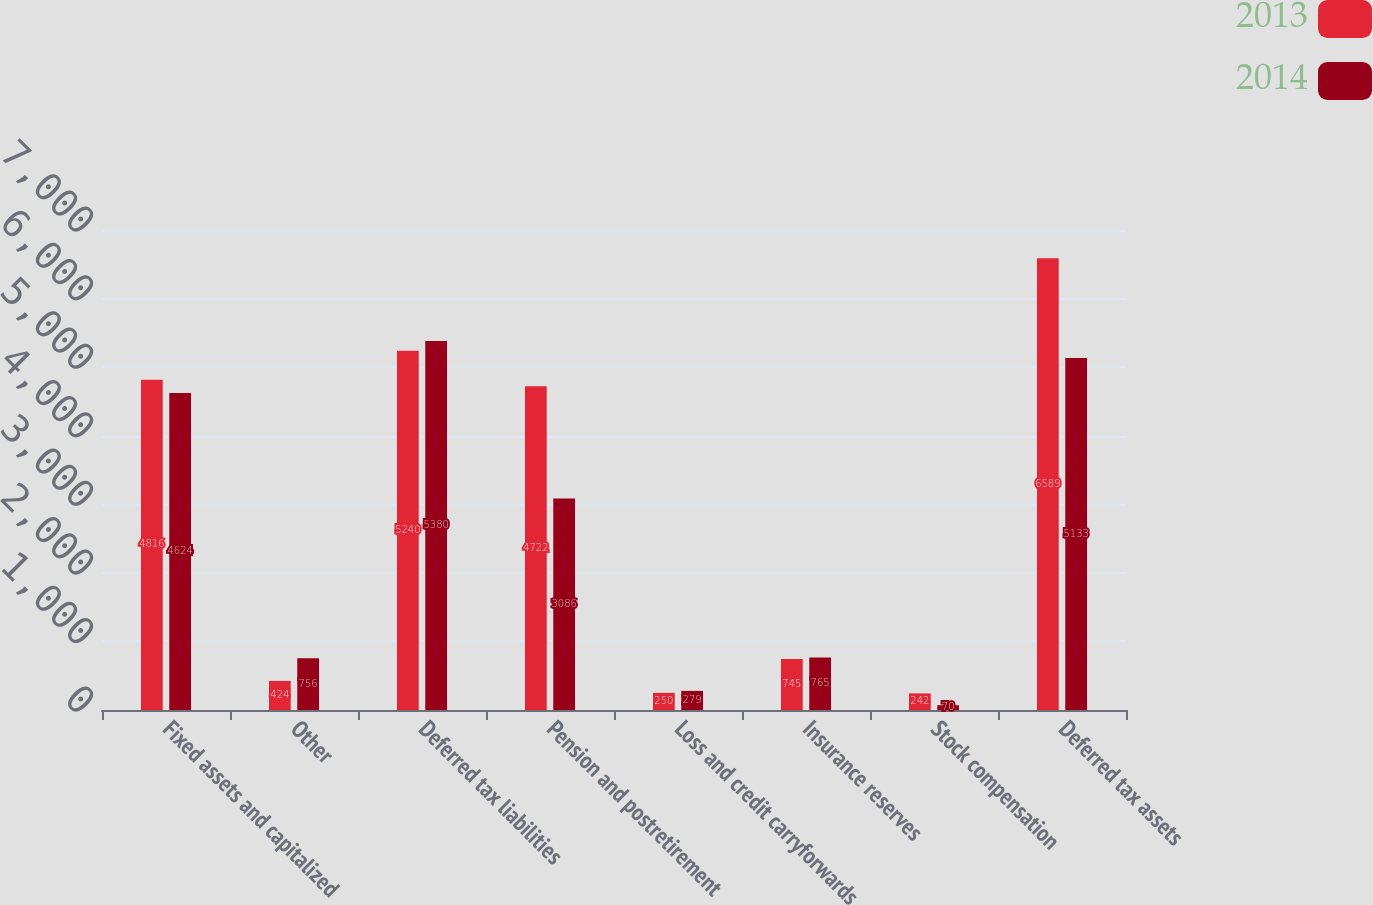Convert chart to OTSL. <chart><loc_0><loc_0><loc_500><loc_500><stacked_bar_chart><ecel><fcel>Fixed assets and capitalized<fcel>Other<fcel>Deferred tax liabilities<fcel>Pension and postretirement<fcel>Loss and credit carryforwards<fcel>Insurance reserves<fcel>Stock compensation<fcel>Deferred tax assets<nl><fcel>2013<fcel>4816<fcel>424<fcel>5240<fcel>4722<fcel>250<fcel>745<fcel>242<fcel>6589<nl><fcel>2014<fcel>4624<fcel>756<fcel>5380<fcel>3086<fcel>279<fcel>765<fcel>70<fcel>5133<nl></chart> 